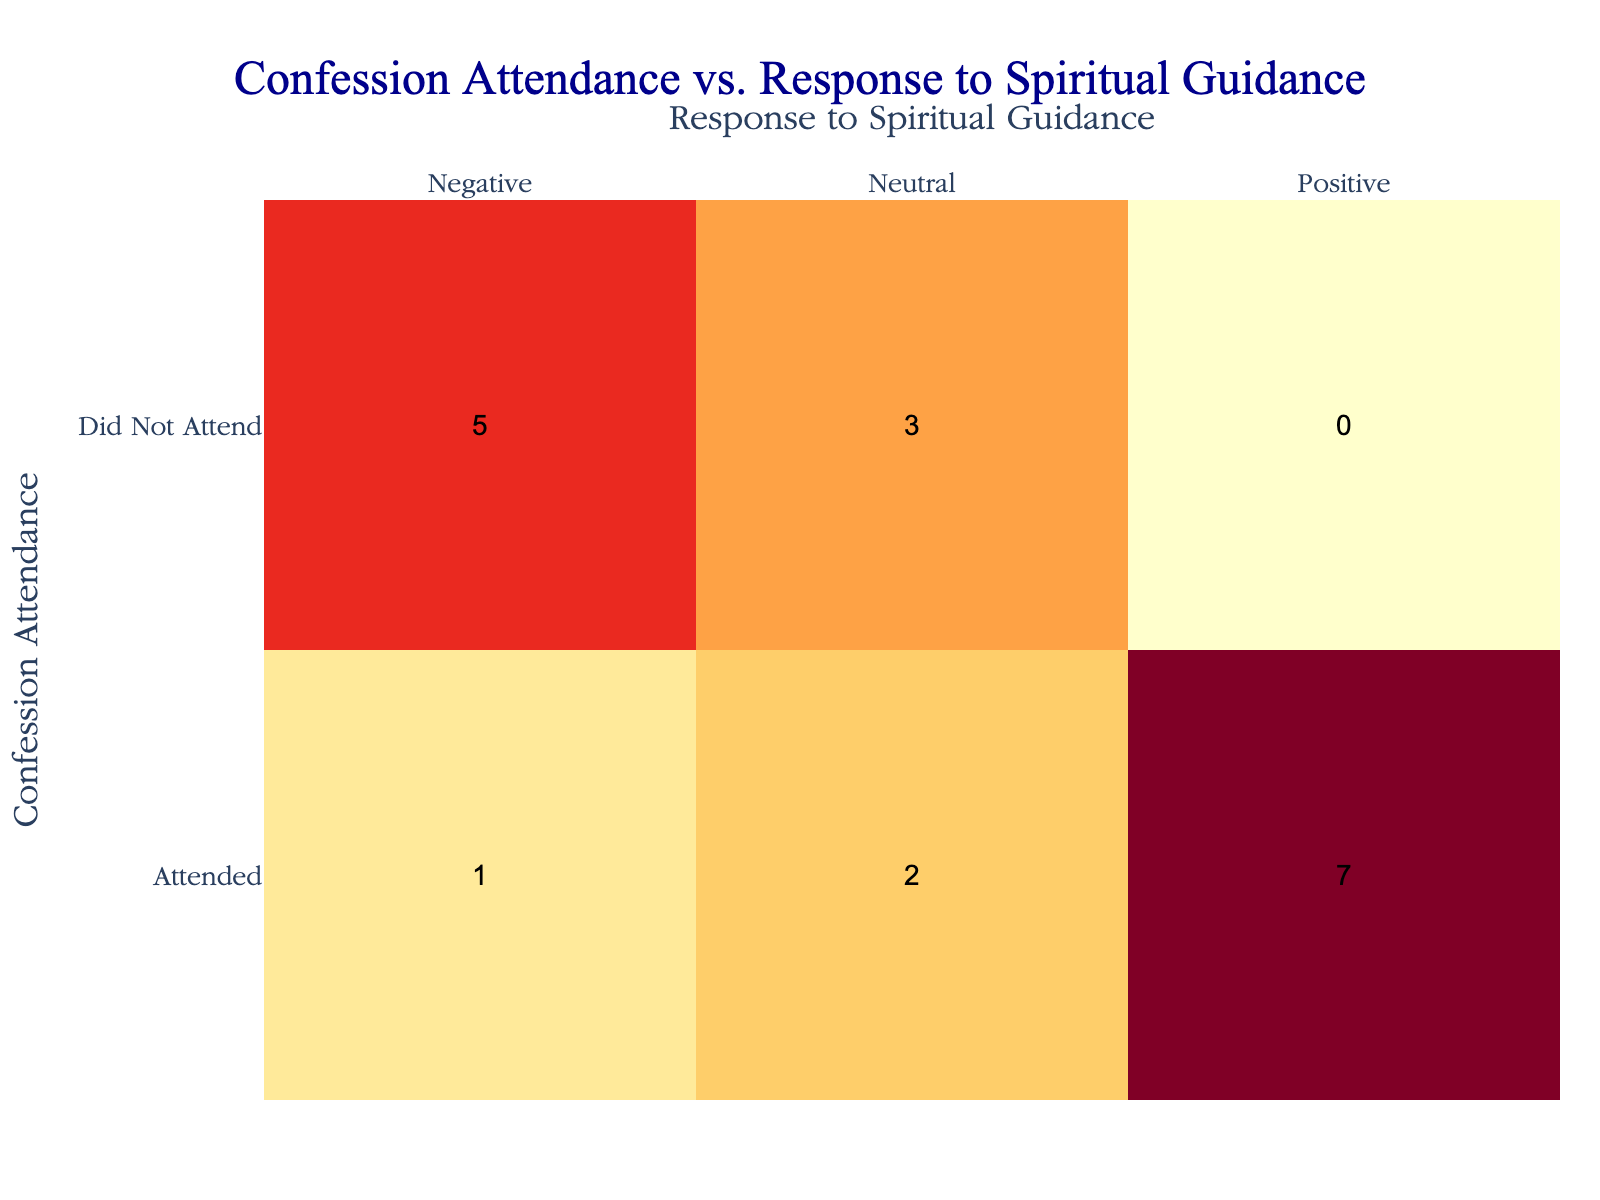What is the total number of people who attended confession and responded positively to spiritual guidance? From the table, we can count the instances of confession attendance for those who responded positively. The age groups are 18-25 (1), 26-35 (1), 36-45 (2), 46-55 (2), 56-65 (1), and 66+ (1). Adding these gives us 1 + 1 + 2 + 2 + 1 + 1 = 8.
Answer: 8 What is the total number of people who did not attend confession but had a negative response to spiritual guidance? We look for individuals who fall into the "Did Not Attend" category and response "Negative". There are 1 person from the 18-25 age group, 1 from the 26-35 age group, 1 from the 46-55 age group, and 1 from the 56-65 age group; so we have 1 + 1 + 1 + 1 = 4.
Answer: 4 How many individuals aged 66 and older responded neutrally to spiritual guidance? In the age group 66+, we can see that there are 1 individual who did not attend confession and responded neutrally.
Answer: 1 Is there any age group where all who attended confession responded positively? Looking at the table, the age groups of 46-55 and 36-45 both have individuals who attended confession and responded positively. However, the group 46-55 contains only positive responses for the attendees which means 100% positive feedback.
Answer: Yes What is the difference in the number of positive responses to spiritual guidance between attendees and non-attendees for the age group 56-65? In the age group 56-65, there are 1 positive response and 0 positive responses from those who did not attend confession. The difference is 1 - 0 = 1.
Answer: 1 How many total attendees responded either positively or neutrally in the age group of 56-65? For the 56-65 age group, 1 person responded positively and 1 responded neutrally, summing these gives us 1 + 1 = 2 attendees with either response.
Answer: 2 Which age group had the highest number of individuals attending confession with negative responses? By examining the table, the age group 36-45 has 1 positive and 1 negative response for attendees while other age groups either have more positive or no negative, meaning 36-45 has a significant share of negative responses from attendees.
Answer: 36-45 How many individuals responded positively overall, regardless of age and attendance status? To find the total number of positive responses, we count all individuals irrespective of other categories; that is, 1 (18-25) + 1 (26-35) + 2 (36-45) + 2 (46-55) + 1 (56-65) + 1 (66+) = 8 total positive responses.
Answer: 8 